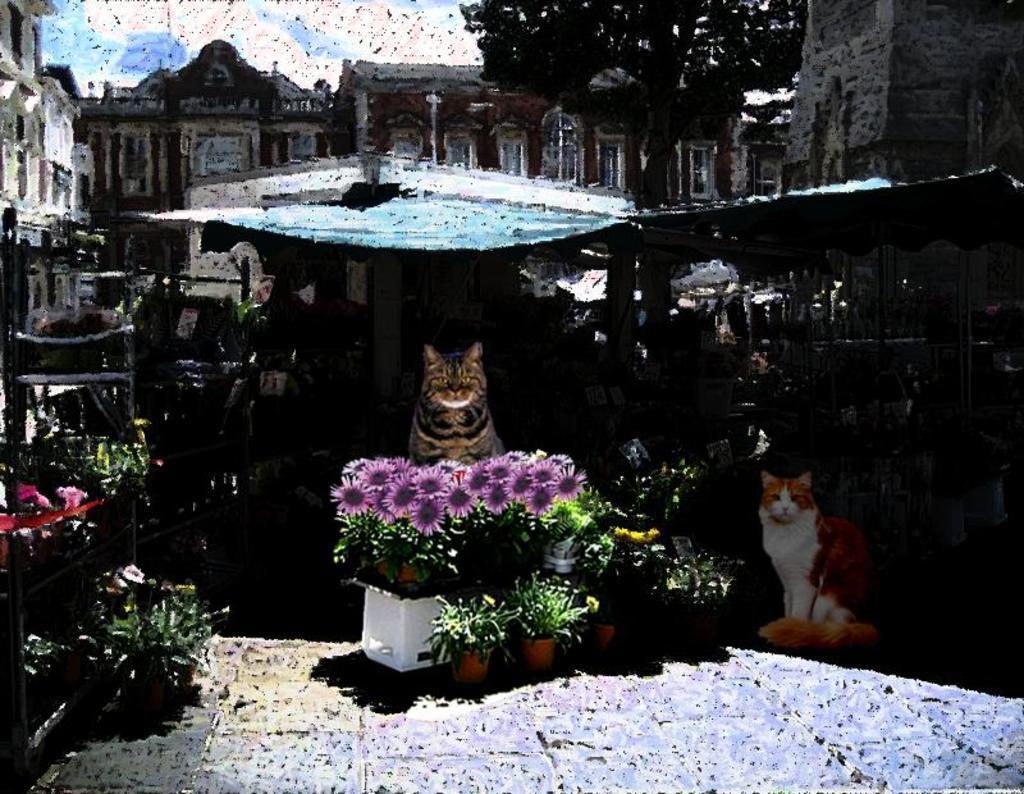Describe this image in one or two sentences. In the given image i can see a buildings,trees,plants,flowers,cats and in the background i can see the sky. 